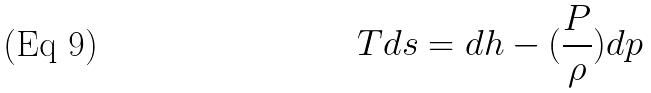<formula> <loc_0><loc_0><loc_500><loc_500>T d s = d h - ( \frac { P } { \rho } ) d p</formula> 